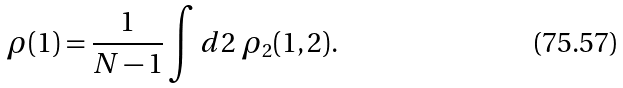<formula> <loc_0><loc_0><loc_500><loc_500>\rho ( 1 ) = \frac { 1 } { N - 1 } \int d 2 \ \rho _ { 2 } ( 1 , 2 ) .</formula> 